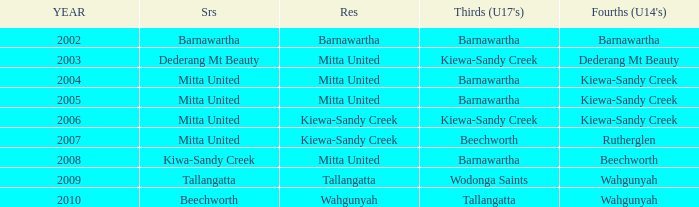Which seniors have a year before 2007, Fourths (Under 14's) of kiewa-sandy creek, and a Reserve of mitta united? Mitta United, Mitta United. 